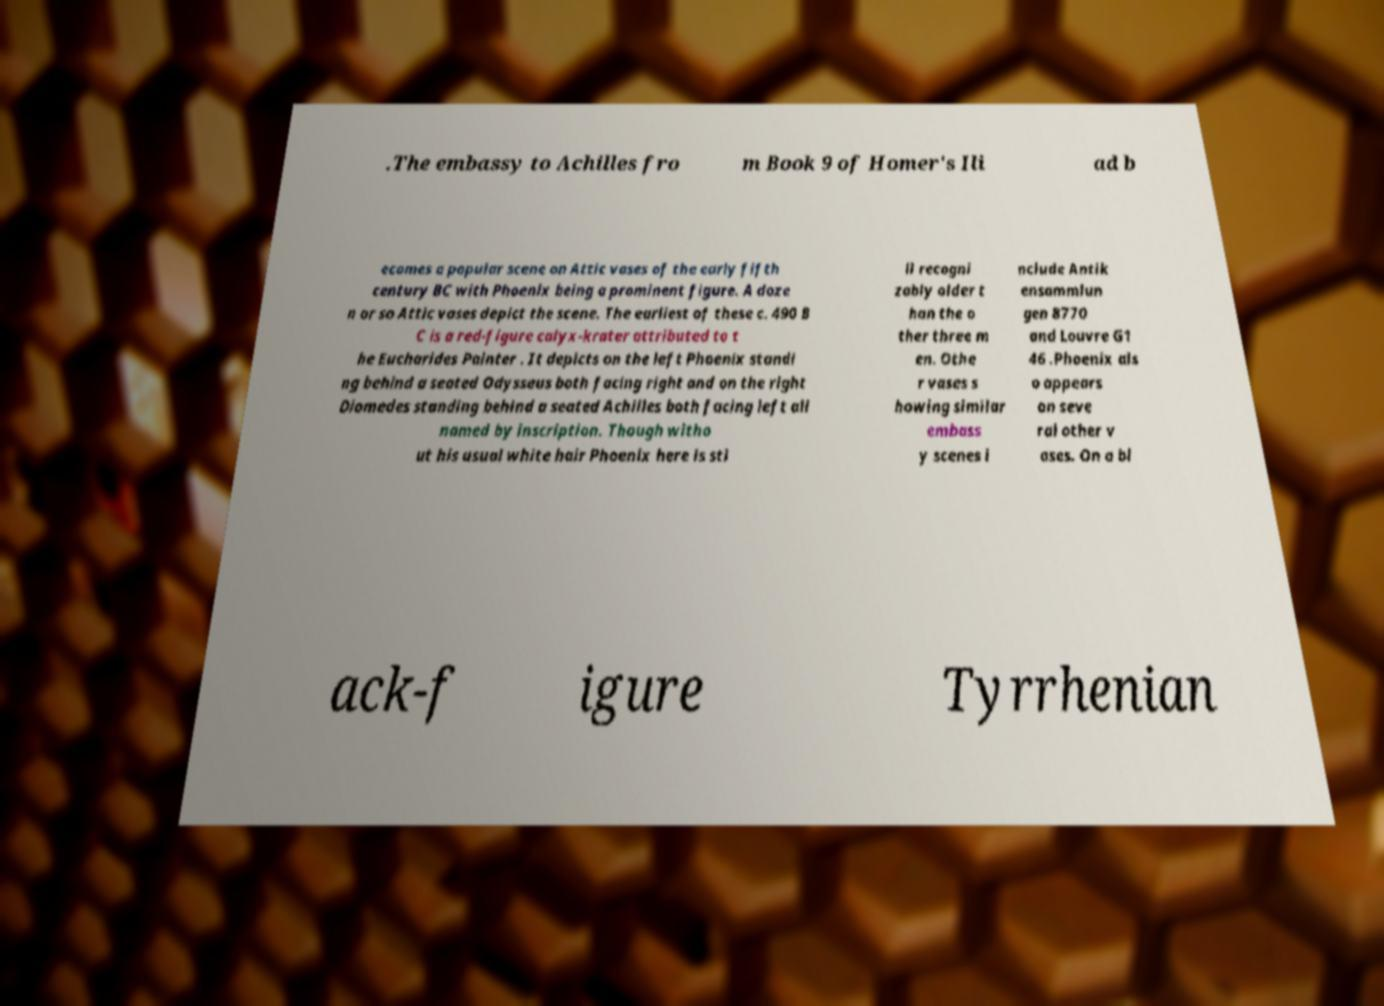Please read and relay the text visible in this image. What does it say? .The embassy to Achilles fro m Book 9 of Homer's Ili ad b ecomes a popular scene on Attic vases of the early fifth century BC with Phoenix being a prominent figure. A doze n or so Attic vases depict the scene. The earliest of these c. 490 B C is a red-figure calyx-krater attributed to t he Eucharides Painter . It depicts on the left Phoenix standi ng behind a seated Odysseus both facing right and on the right Diomedes standing behind a seated Achilles both facing left all named by inscription. Though witho ut his usual white hair Phoenix here is sti ll recogni zably older t han the o ther three m en. Othe r vases s howing similar embass y scenes i nclude Antik ensammlun gen 8770 and Louvre G1 46 .Phoenix als o appears on seve ral other v ases. On a bl ack-f igure Tyrrhenian 